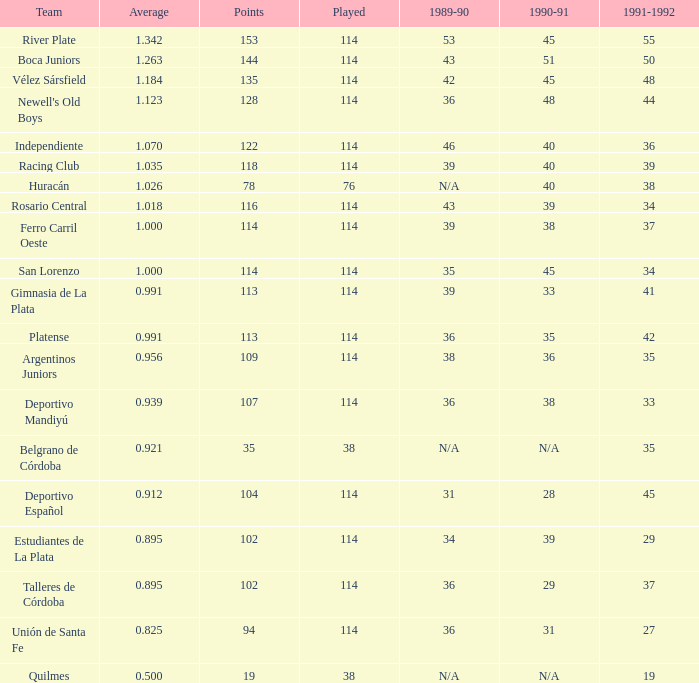How much 1991-1992 has a Team of gimnasia de la plata, and more than 113 points? 0.0. 